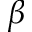<formula> <loc_0><loc_0><loc_500><loc_500>\beta</formula> 